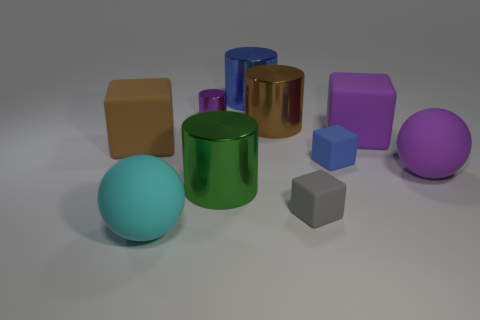What associations can one make based on the arrangement of the objects? The arrangement presents an interesting interplay of geometric forms that may suggest multiple associations. For example, it could be seen as a representation of diversity, with different shapes and colors coexisting harmoniously. Also, the variation in sizes could symbolize hierarchy or scale in social structures or even different sized entities in astronomical terms, with smaller shapes representing moons or satellites and the larger shapes akin to planets. 